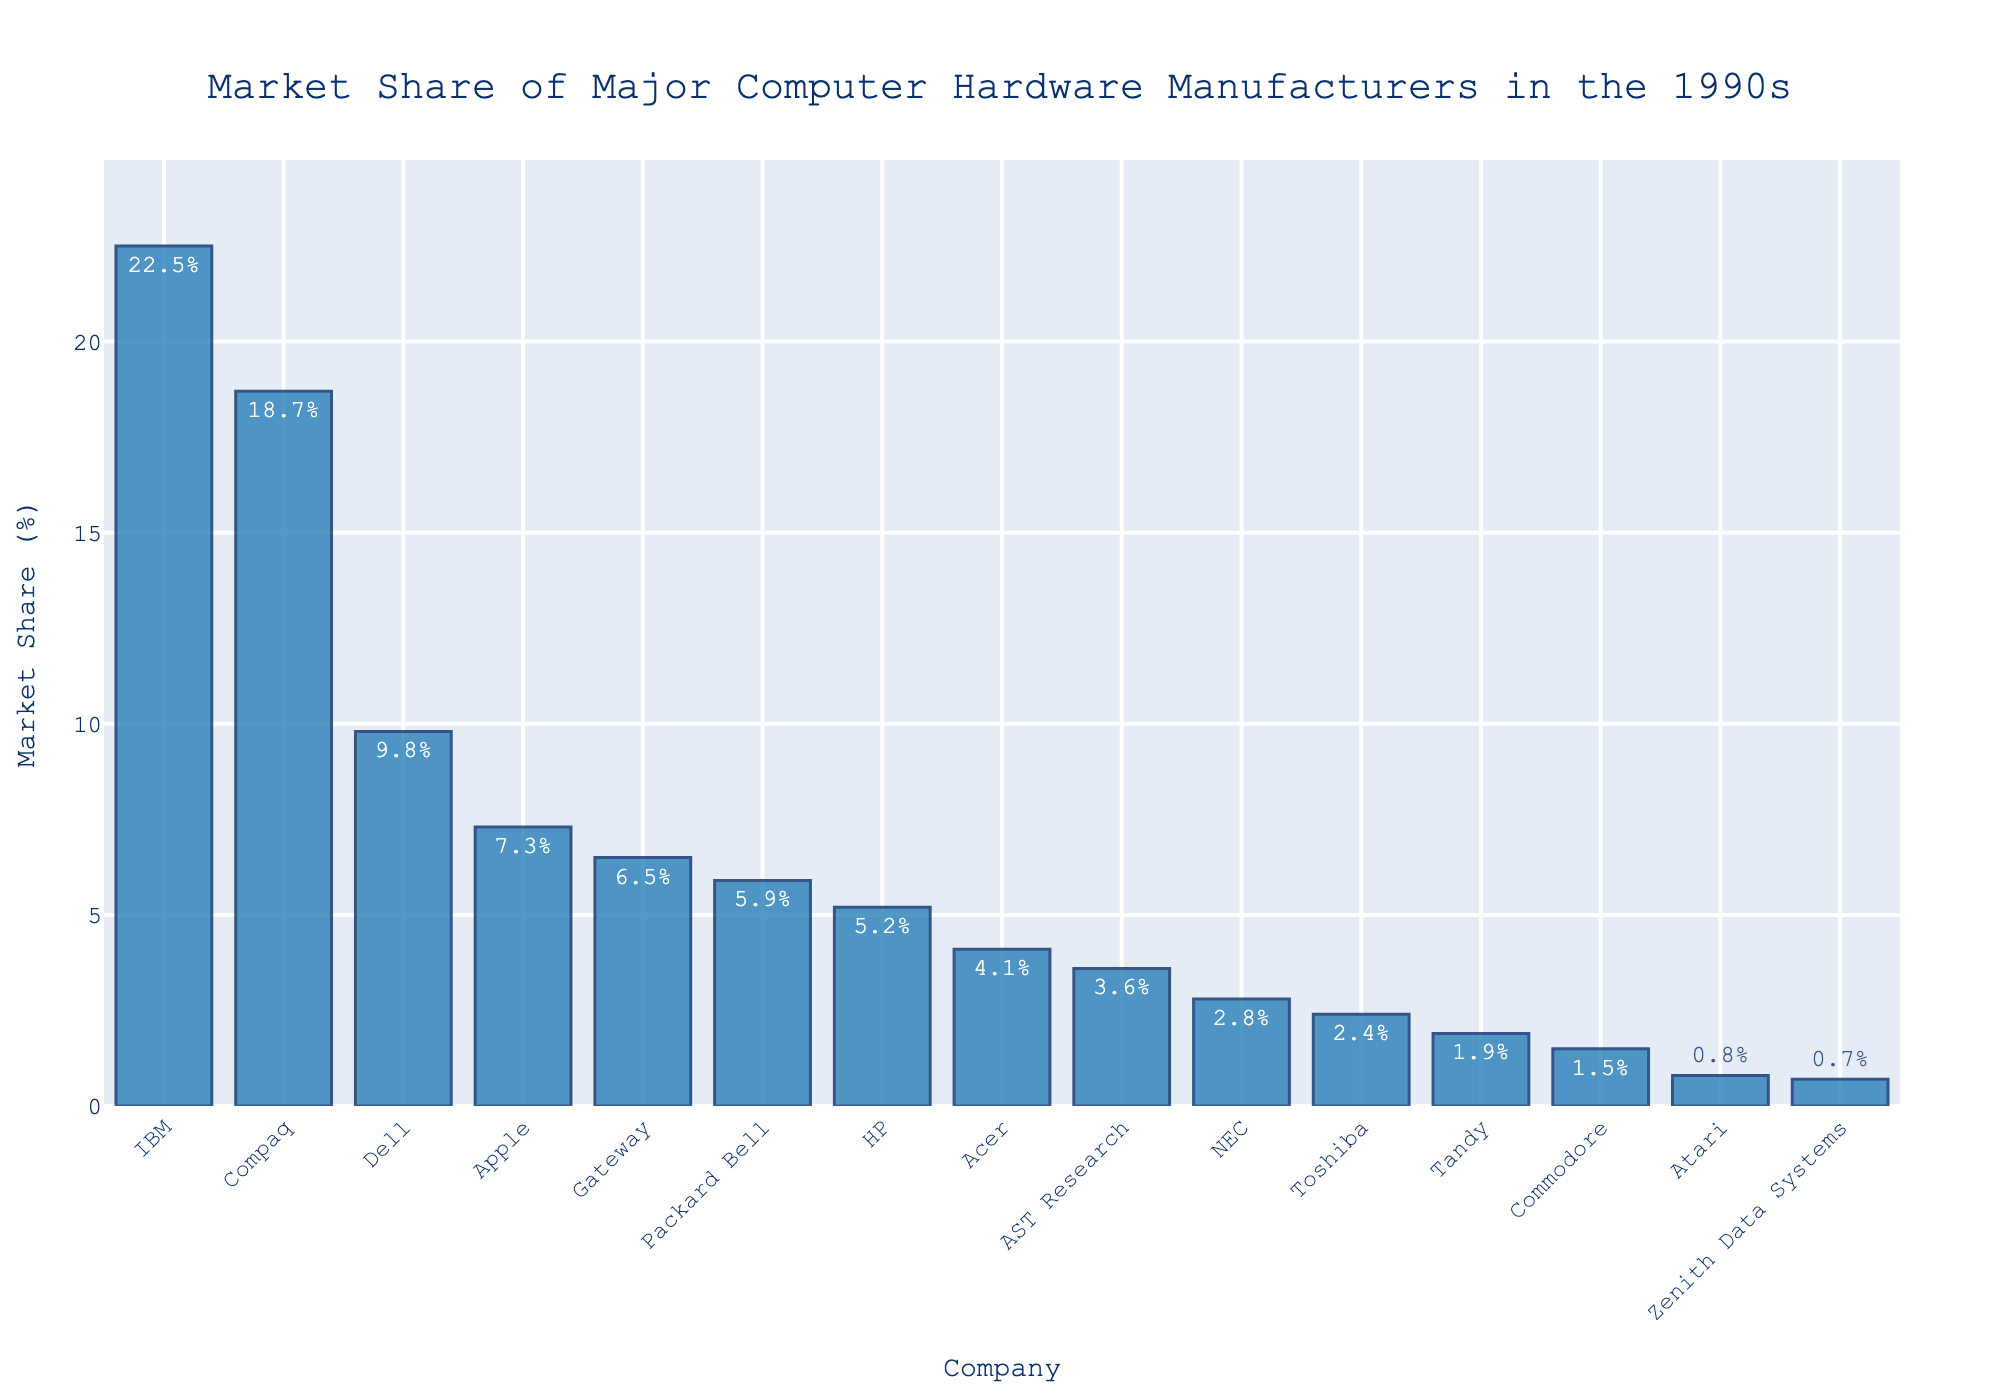What company has the highest market share? The bar chart shows that IBM has the tallest bar, indicating IBM has the highest market share.
Answer: IBM Which company ranks second in market share? The second tallest bar represents the company with the second highest market share, which is Compaq.
Answer: Compaq How much market share does Dell have compared to Apple? Dell has a market share of 9.8%, and Apple has a market share of 7.3%. To compare them, 9.8% - 7.3% = 2.5%. Dell has 2.5% more market share than Apple.
Answer: 2.5% What is the total market share of the top three companies? The top three companies by market share are IBM (22.5%), Compaq (18.7%), and Dell (9.8%). Adding these gives 22.5% + 18.7% + 9.8% = 51%.
Answer: 51% Which companies have a market share of less than 2%? The companies with market shares less than 2% are Tandy (1.9%), Commodore (1.5%), Atari (0.8%), and Zenith Data Systems (0.7%).
Answer: Tandy, Commodore, Atari, Zenith Data Systems How does the market share of Gateway compare to that of Packard Bell? Gateway's market share is 6.5%, while Packard Bell's is 5.9%. The difference is 6.5% - 5.9% = 0.6%. Gateway has a 0.6% higher market share than Packard Bell.
Answer: 0.6% What is the average market share of the bottom five companies? The bottom five companies are Tandy (1.9%), Commodore (1.5%), Atari (0.8%), Zenith Data Systems (0.7%), and NEC (2.8%). The average is calculated as (1.9% + 1.5% + 0.8% + 0.7% + 2.8%) / 5 = 7.7% / 5 = 1.54%.
Answer: 1.54% Which company has a market share closest to 5%? The bar representing Hewlett-Packard (HP) has a market share of 5.2%, which is closest to 5%.
Answer: HP What is the combined market share of Acer and AST Research? Acer has a market share of 4.1%, and AST Research has 3.6%. Their combined market share is 4.1% + 3.6% = 7.7%.
Answer: 7.7% How many companies have a market share of over 10%? By examining the bars, IBM (22.5%) and Compaq (18.7%) are the only companies with a market share over 10%, making a total of 2 companies.
Answer: 2 